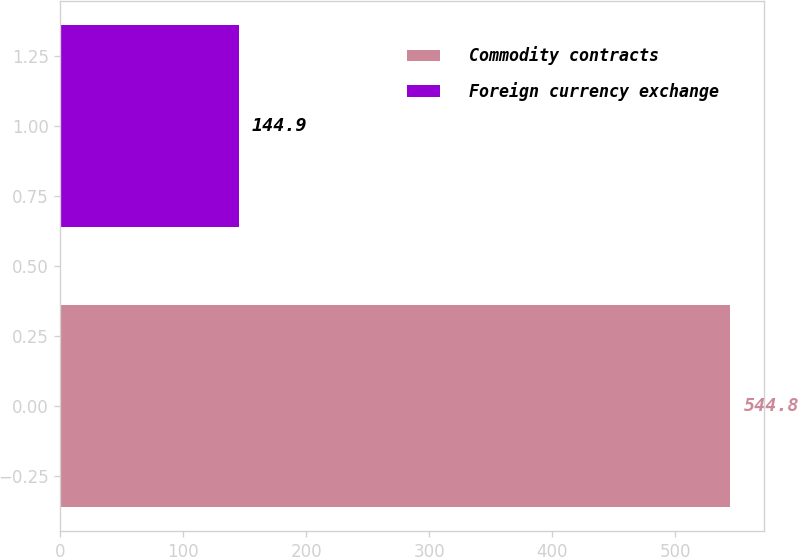Convert chart to OTSL. <chart><loc_0><loc_0><loc_500><loc_500><bar_chart><fcel>Commodity contracts<fcel>Foreign currency exchange<nl><fcel>544.8<fcel>144.9<nl></chart> 